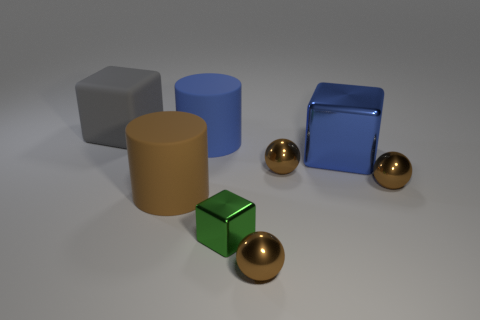Subtract all big cubes. How many cubes are left? 1 Add 1 big gray cubes. How many objects exist? 9 Subtract all cylinders. How many objects are left? 6 Add 2 brown matte cylinders. How many brown matte cylinders exist? 3 Subtract all brown cylinders. How many cylinders are left? 1 Subtract 1 brown cylinders. How many objects are left? 7 Subtract 1 balls. How many balls are left? 2 Subtract all cyan balls. Subtract all cyan blocks. How many balls are left? 3 Subtract all blue balls. How many blue cylinders are left? 1 Subtract all blue matte cylinders. Subtract all large gray metallic objects. How many objects are left? 7 